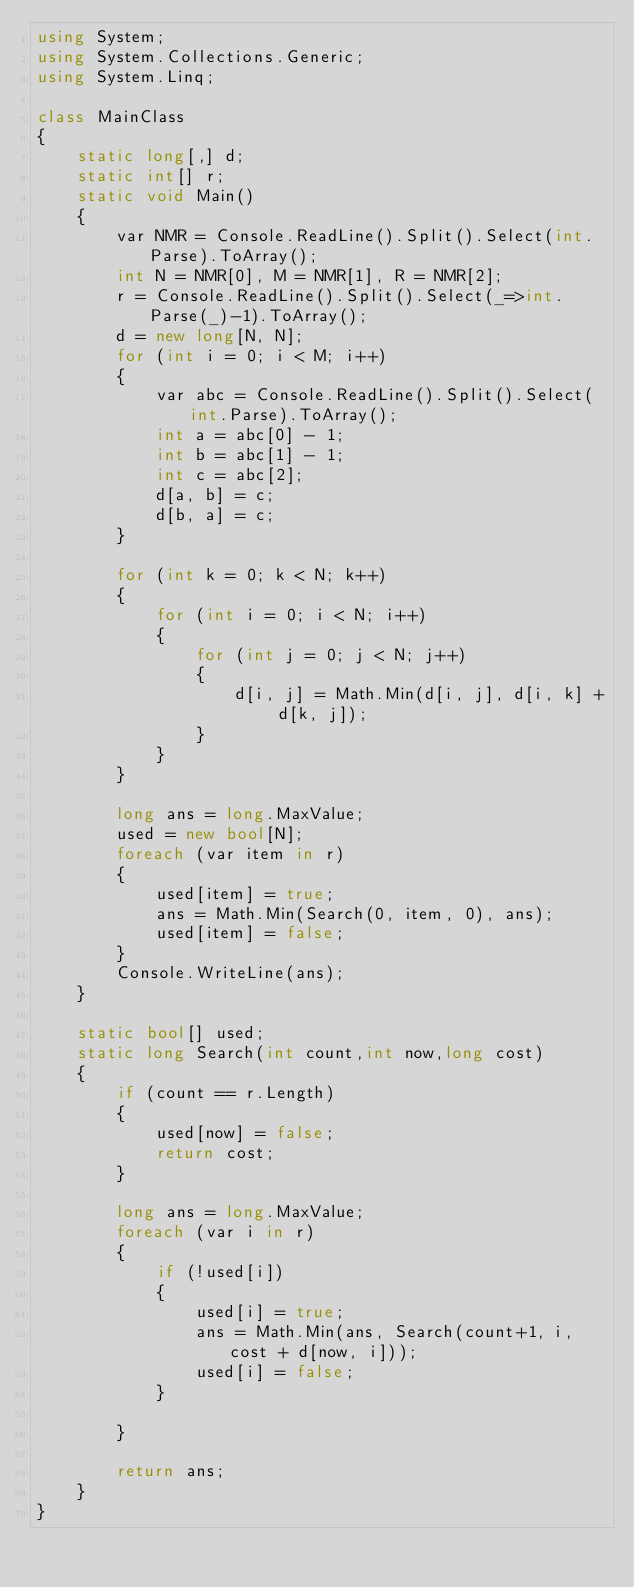<code> <loc_0><loc_0><loc_500><loc_500><_C#_>using System;
using System.Collections.Generic;
using System.Linq;

class MainClass
{
    static long[,] d;
    static int[] r;
    static void Main()
    {
        var NMR = Console.ReadLine().Split().Select(int.Parse).ToArray();
        int N = NMR[0], M = NMR[1], R = NMR[2];
        r = Console.ReadLine().Split().Select(_=>int.Parse(_)-1).ToArray();
        d = new long[N, N];
        for (int i = 0; i < M; i++)
        {
            var abc = Console.ReadLine().Split().Select(int.Parse).ToArray();
            int a = abc[0] - 1;
            int b = abc[1] - 1;
            int c = abc[2];
            d[a, b] = c;
            d[b, a] = c;
        }

        for (int k = 0; k < N; k++)
        {
            for (int i = 0; i < N; i++)
            {
                for (int j = 0; j < N; j++)
                {
                    d[i, j] = Math.Min(d[i, j], d[i, k] + d[k, j]);
                }
            }
        }

        long ans = long.MaxValue;
        used = new bool[N];
        foreach (var item in r)
        {
            used[item] = true;
            ans = Math.Min(Search(0, item, 0), ans);
            used[item] = false;
        }
        Console.WriteLine(ans);
    }

    static bool[] used;
    static long Search(int count,int now,long cost)
    {
        if (count == r.Length)
        {
            used[now] = false;
            return cost;
        }
        
        long ans = long.MaxValue;
        foreach (var i in r)
        {
            if (!used[i])
            {
                used[i] = true;
                ans = Math.Min(ans, Search(count+1, i, cost + d[now, i]));
                used[i] = false;
            }
                
        }

        return ans;
    }
}
</code> 